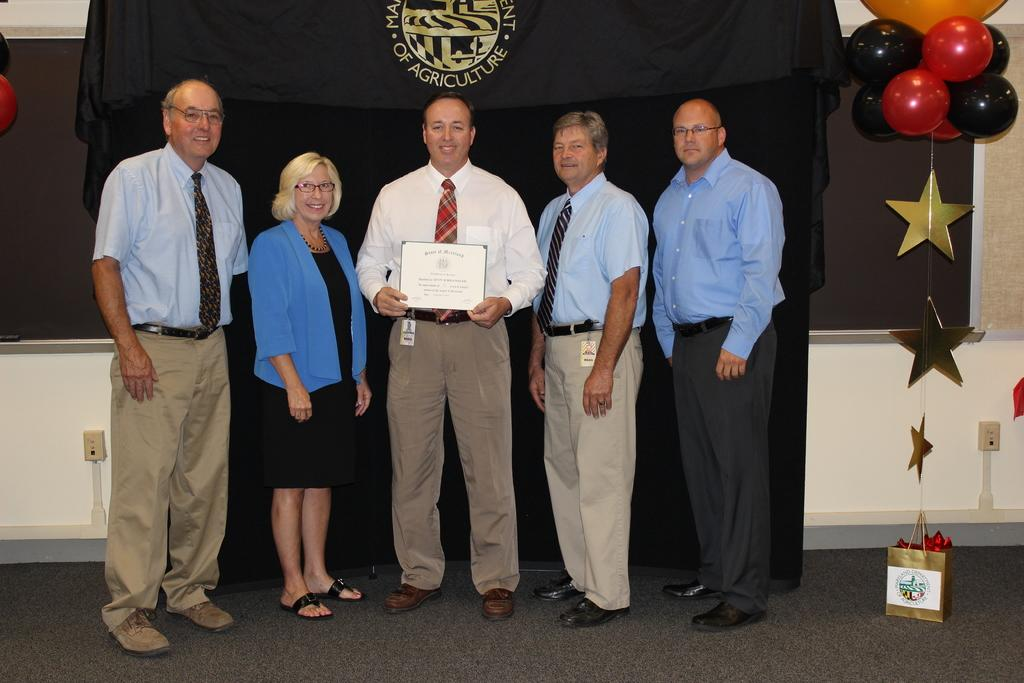How many people are present in the image? There are five people in the image. What is one person doing in the image? One person is holding an object. Can you describe any other items in the image? There is a bag, stars, balloons, and a cloth in the image. What type of polish is being applied to the eggs in the image? There is no polish or eggs present in the image. How much money is visible in the image? There is no money visible in the image. 